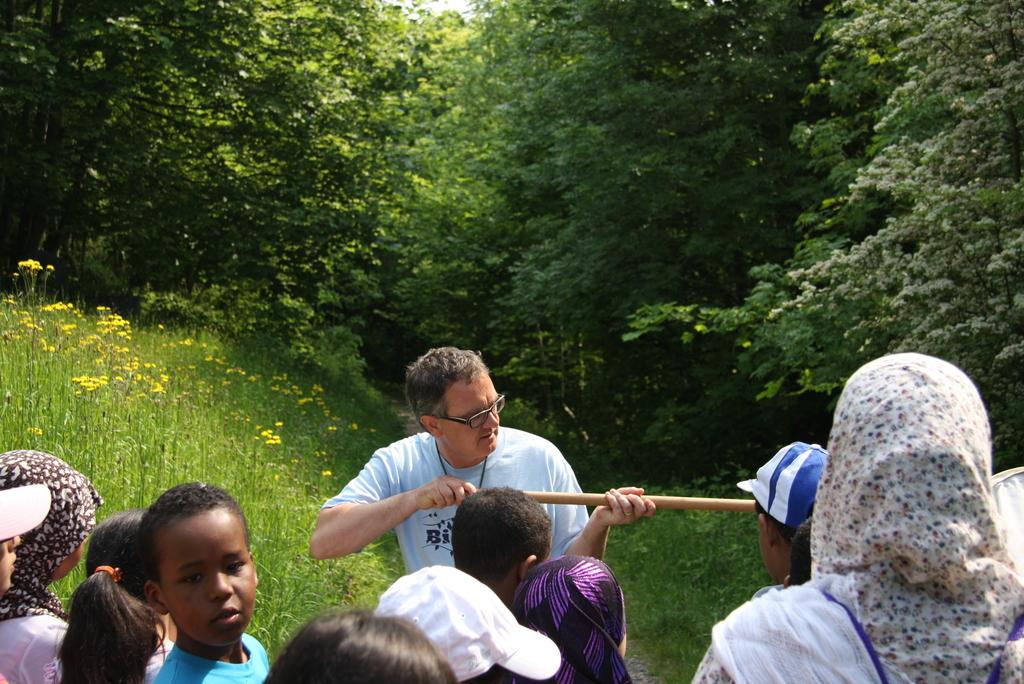How many people are in the image? There is a group of people in the image. What is the person with spectacles holding? The person with spectacles is holding a stick. What type of vegetation can be seen in the background of the image? There are plants with flowers and trees in the background of the image. What is visible in the sky in the image? The sky is visible in the background of the image. What invention is being demonstrated by the person with spectacles in the image? There is no invention being demonstrated in the image; the person with spectacles is simply holding a stick. 